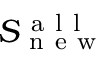<formula> <loc_0><loc_0><loc_500><loc_500>S _ { n e w } ^ { a l l }</formula> 